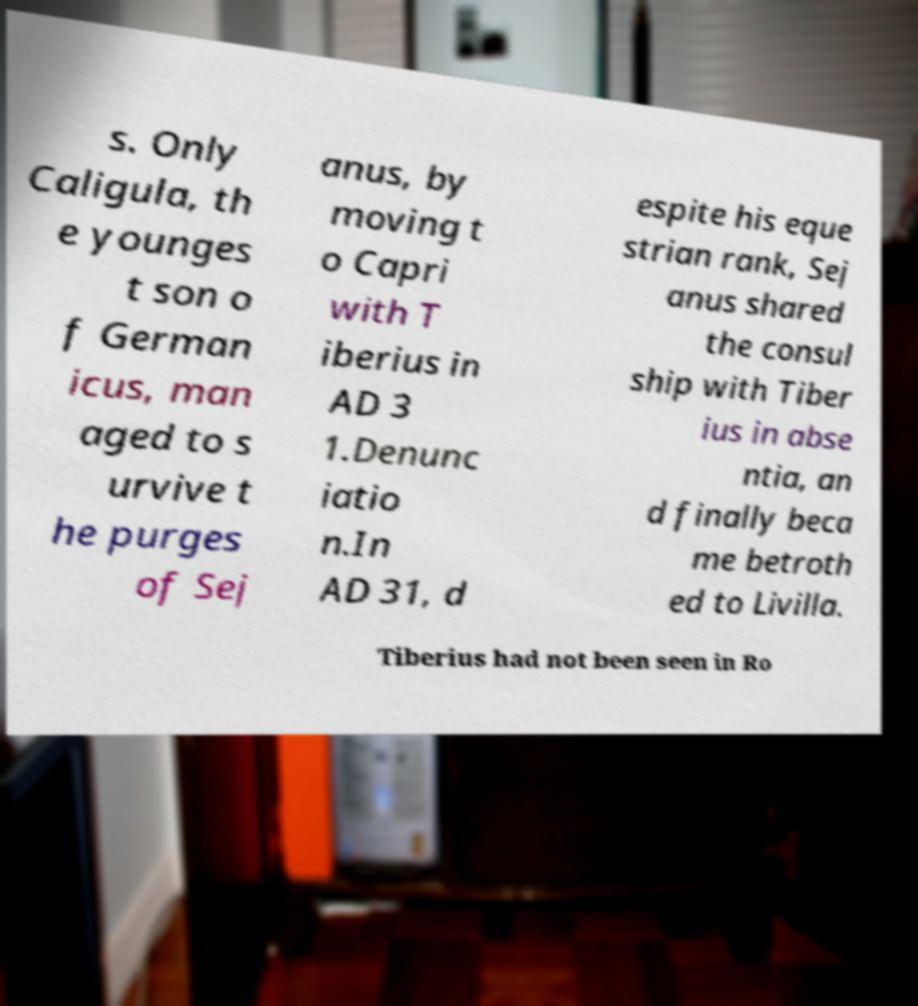Please read and relay the text visible in this image. What does it say? s. Only Caligula, th e younges t son o f German icus, man aged to s urvive t he purges of Sej anus, by moving t o Capri with T iberius in AD 3 1.Denunc iatio n.In AD 31, d espite his eque strian rank, Sej anus shared the consul ship with Tiber ius in abse ntia, an d finally beca me betroth ed to Livilla. Tiberius had not been seen in Ro 